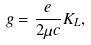<formula> <loc_0><loc_0><loc_500><loc_500>g = \frac { e } { 2 \mu c } K _ { L } ,</formula> 